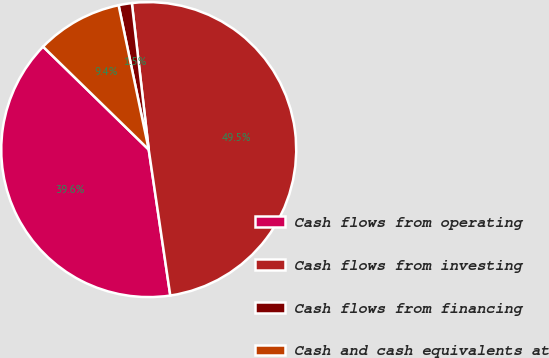Convert chart to OTSL. <chart><loc_0><loc_0><loc_500><loc_500><pie_chart><fcel>Cash flows from operating<fcel>Cash flows from investing<fcel>Cash flows from financing<fcel>Cash and cash equivalents at<nl><fcel>39.63%<fcel>49.49%<fcel>1.45%<fcel>9.43%<nl></chart> 